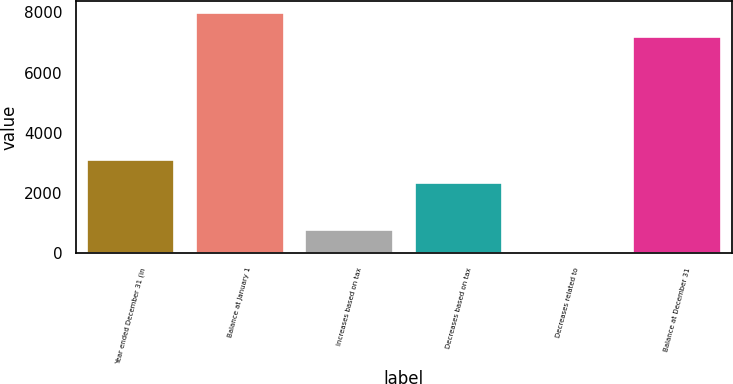Convert chart to OTSL. <chart><loc_0><loc_0><loc_500><loc_500><bar_chart><fcel>Year ended December 31 (in<fcel>Balance at January 1<fcel>Increases based on tax<fcel>Decreases based on tax<fcel>Decreases related to<fcel>Balance at December 31<nl><fcel>3116.4<fcel>7964.1<fcel>791.1<fcel>2341.3<fcel>16<fcel>7189<nl></chart> 